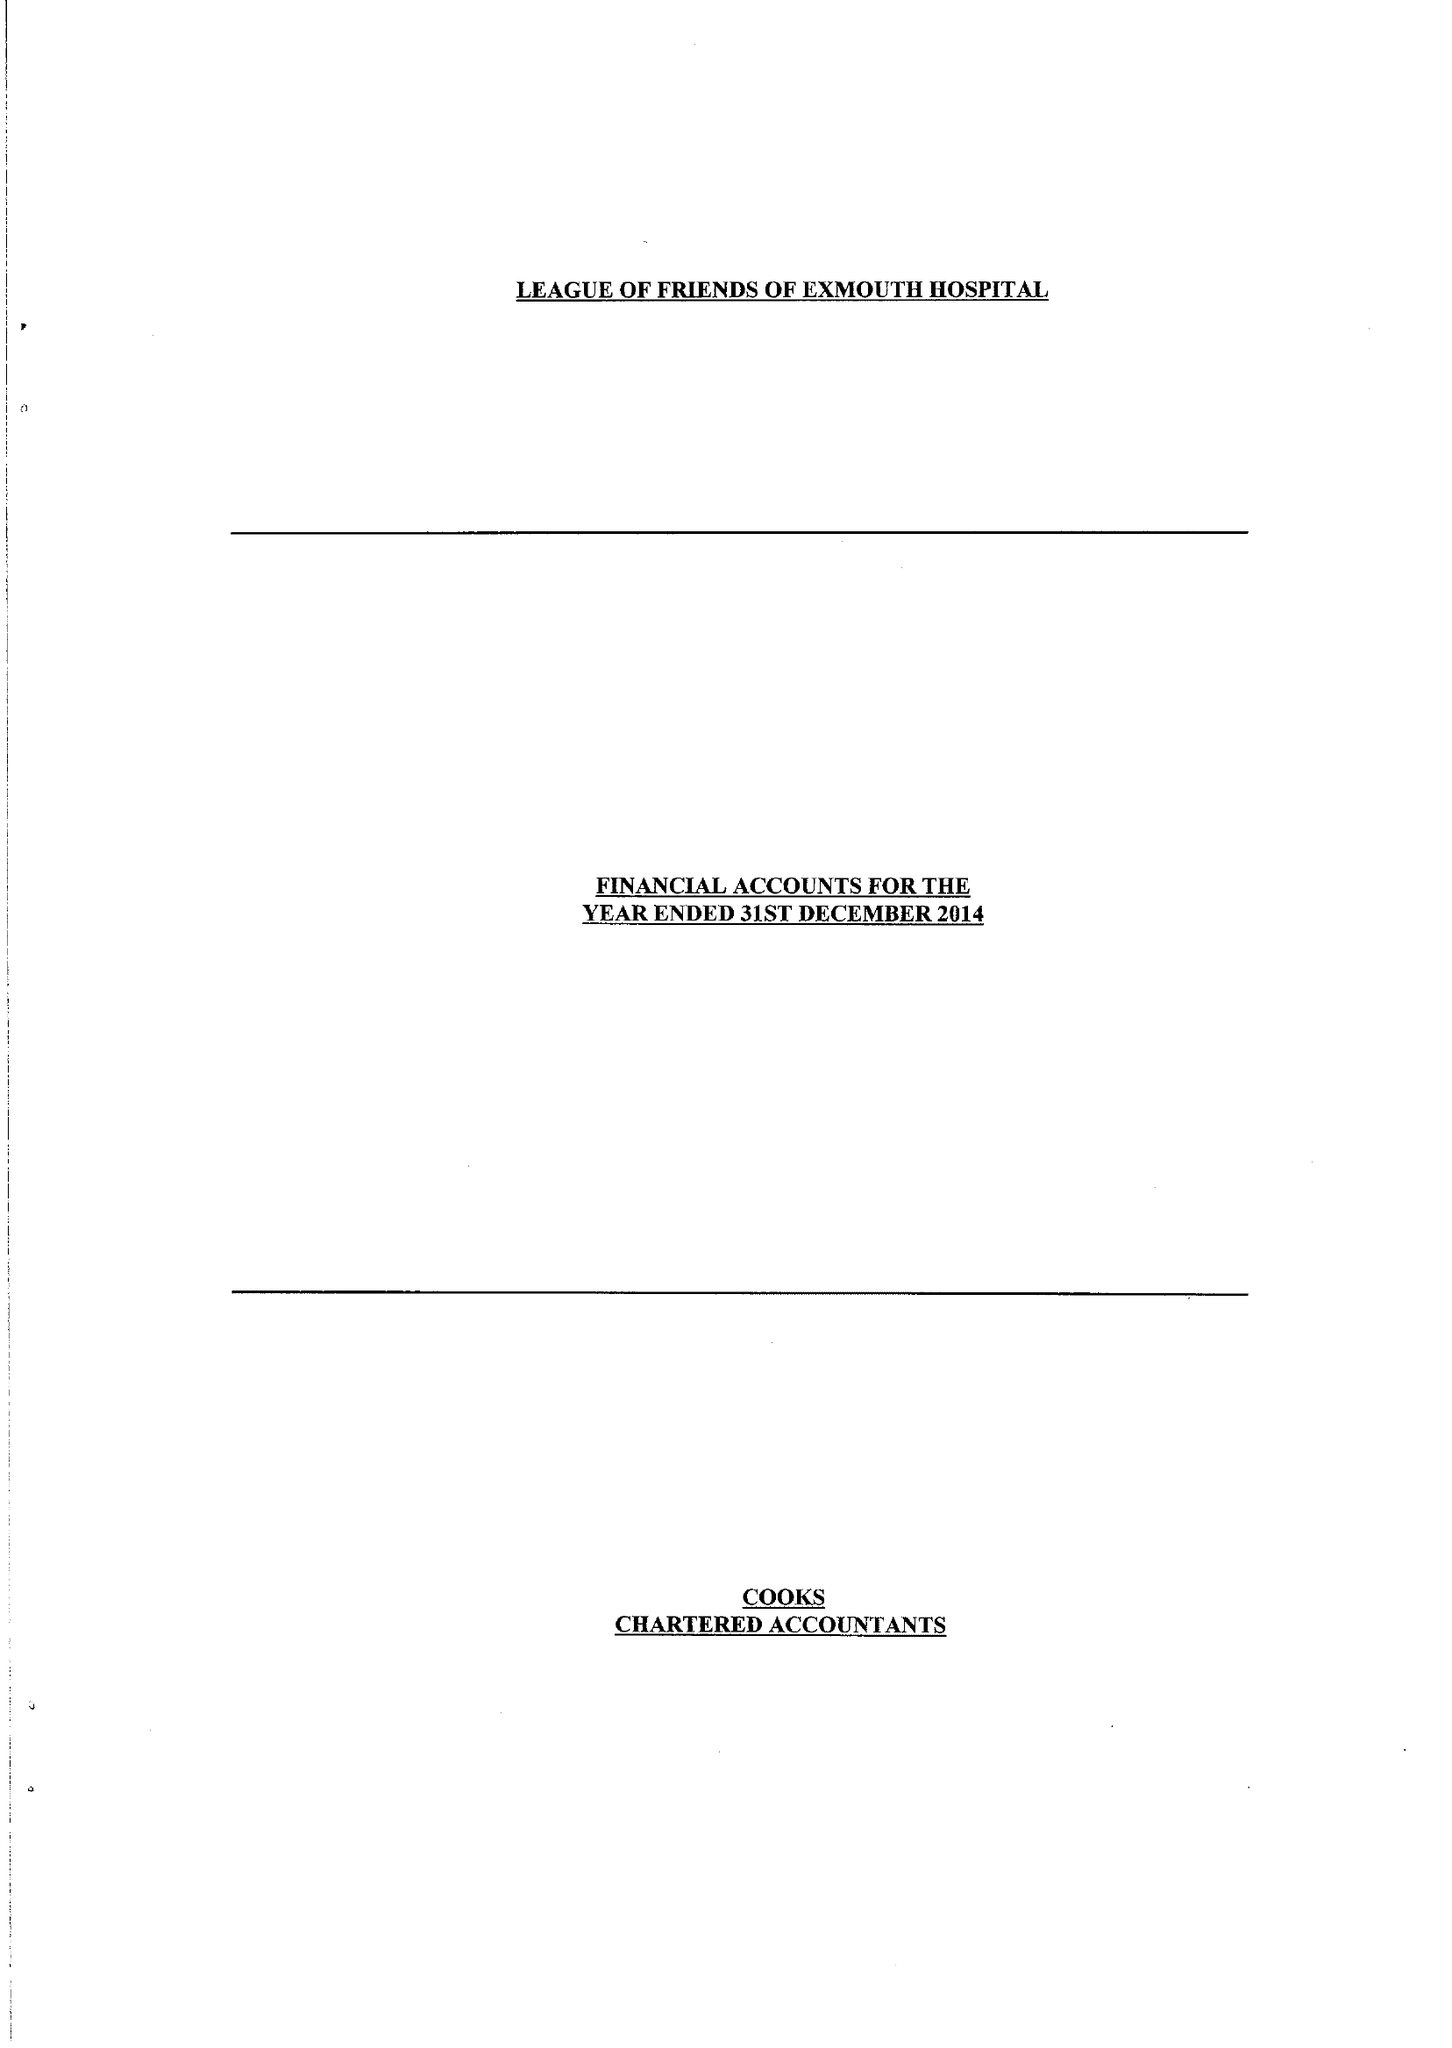What is the value for the address__post_town?
Answer the question using a single word or phrase. EXMOUTH 